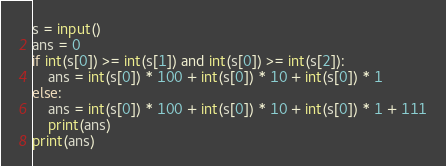<code> <loc_0><loc_0><loc_500><loc_500><_Python_>s = input()
ans = 0
if int(s[0]) >= int(s[1]) and int(s[0]) >= int(s[2]):
    ans = int(s[0]) * 100 + int(s[0]) * 10 + int(s[0]) * 1
else:
    ans = int(s[0]) * 100 + int(s[0]) * 10 + int(s[0]) * 1 + 111
    print(ans)
print(ans)
</code> 